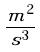<formula> <loc_0><loc_0><loc_500><loc_500>\frac { m ^ { 2 } } { s ^ { 3 } }</formula> 